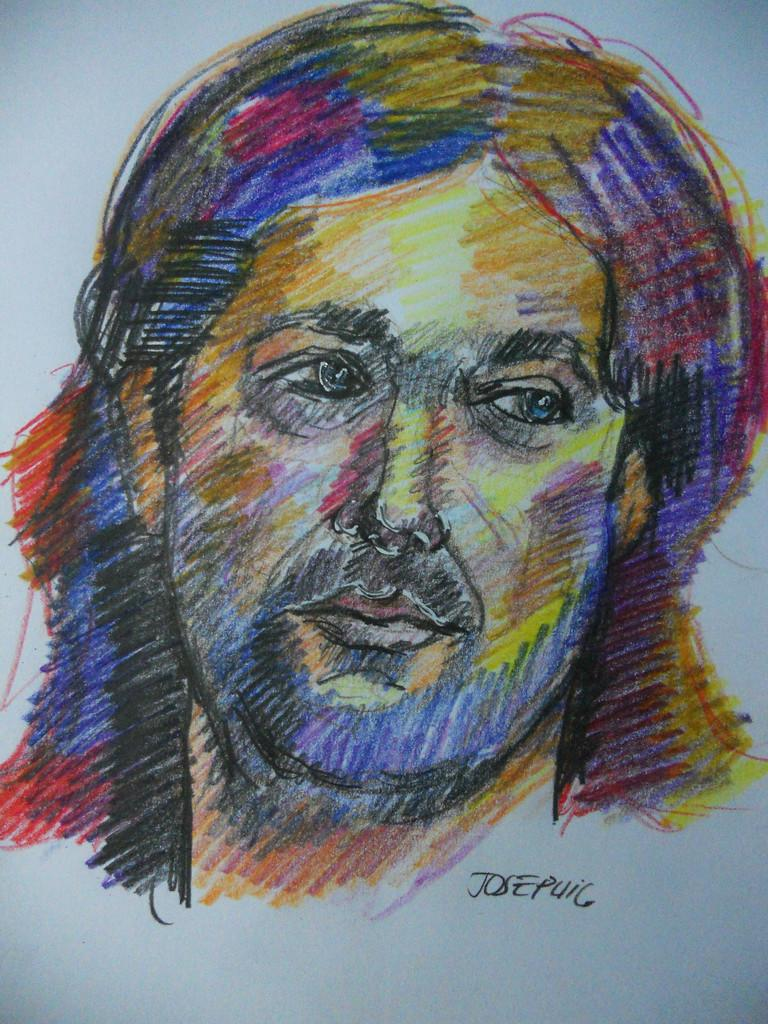What is depicted on the paper in the image? There is a colorful drawing of a person's face on the paper. Can you describe any other details about the drawing? Unfortunately, the provided facts do not mention any other details about the drawing. Is there any text present in the image? Yes, the name is present in the image. What type of sugar is used to create the drawing in the image? There is no mention of sugar being used in the image, as the drawing is created with colorful materials on paper. 